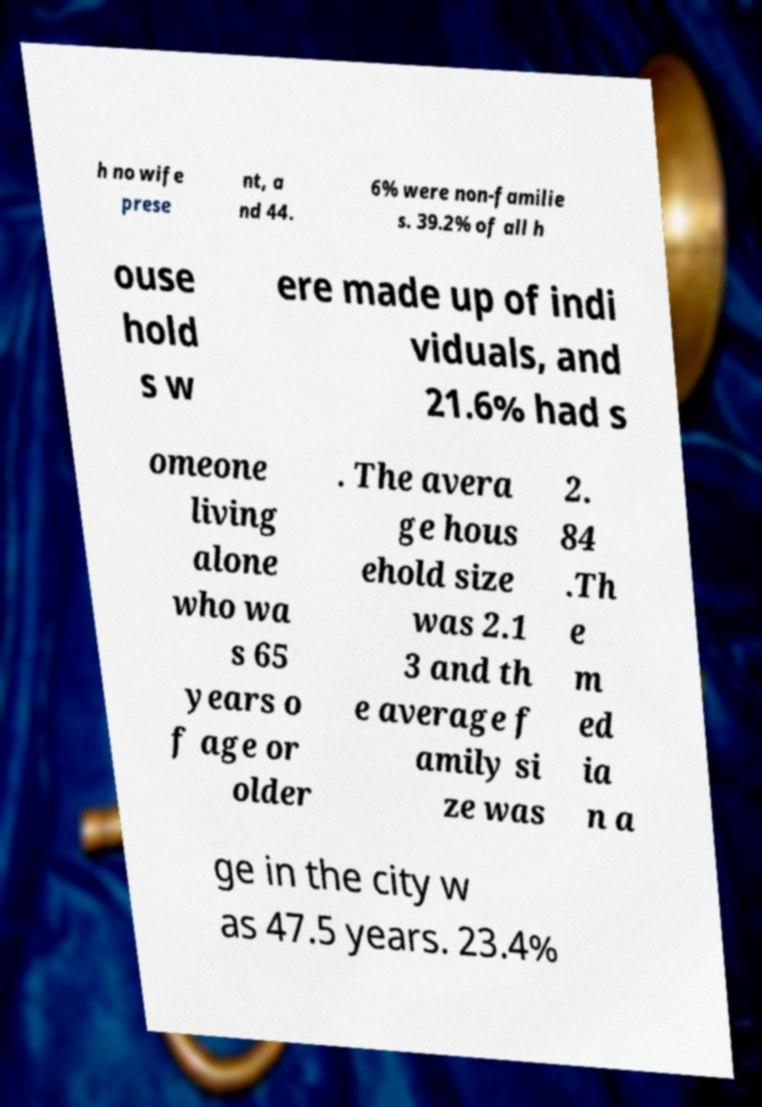Can you accurately transcribe the text from the provided image for me? h no wife prese nt, a nd 44. 6% were non-familie s. 39.2% of all h ouse hold s w ere made up of indi viduals, and 21.6% had s omeone living alone who wa s 65 years o f age or older . The avera ge hous ehold size was 2.1 3 and th e average f amily si ze was 2. 84 .Th e m ed ia n a ge in the city w as 47.5 years. 23.4% 